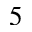<formula> <loc_0><loc_0><loc_500><loc_500>5</formula> 